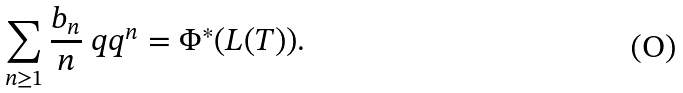Convert formula to latex. <formula><loc_0><loc_0><loc_500><loc_500>\sum _ { n \geq 1 } \frac { b _ { n } } { n } \ q q ^ { n } = \Phi ^ { * } ( L ( T ) ) .</formula> 